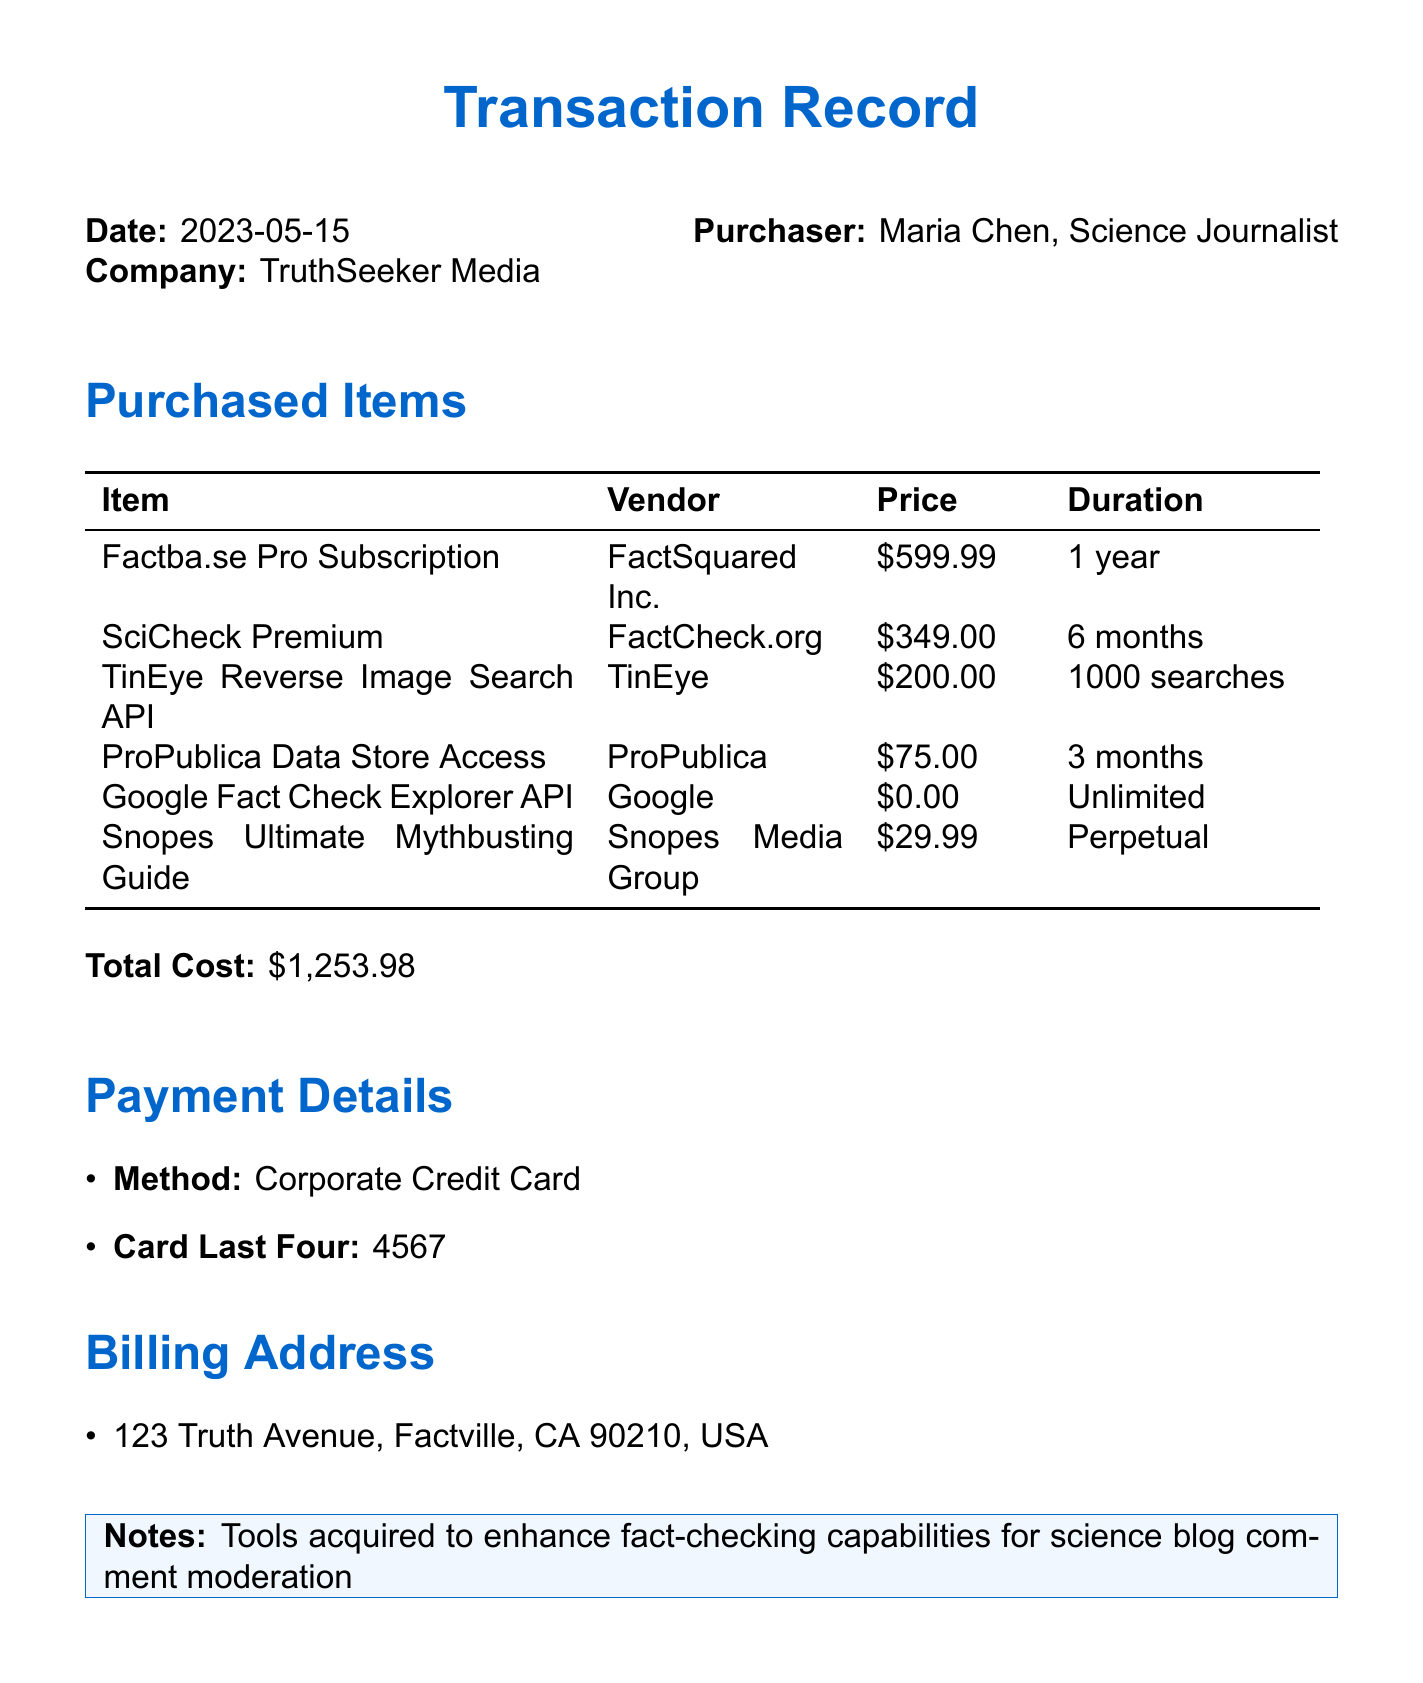What was the total cost of the purchases? The total cost is directly stated in the document as $1,253.98.
Answer: $1,253.98 Who was the purchaser of the tools? The document identifies the purchaser as Maria Chen, a Science Journalist.
Answer: Maria Chen What is the duration of the Factba.se Pro Subscription? The duration for this subscription is specified as 1 year.
Answer: 1 year Which vendor provided the SciCheck Premium tool? The document states that the vendor for SciCheck Premium is FactCheck.org.
Answer: FactCheck.org How many searches does the TinEye Reverse Image Search API allow? The number of searches is listed as 1000 searches.
Answer: 1000 searches What is the price of the Google Fact Check Explorer API? The document indicates that the price for this API is $0.00.
Answer: $0.00 What is noted as the purpose for acquiring these tools? The document includes a note mentioning that the tools were acquired to enhance fact-checking capabilities for comment moderation.
Answer: Enhance fact-checking capabilities for science blog comment moderation What payment method was used for the transaction? Payment method is noted as Corporate Credit Card in the document.
Answer: Corporate Credit Card In which city is the billing address located? The city in the billing address is clearly stated as Factville.
Answer: Factville 